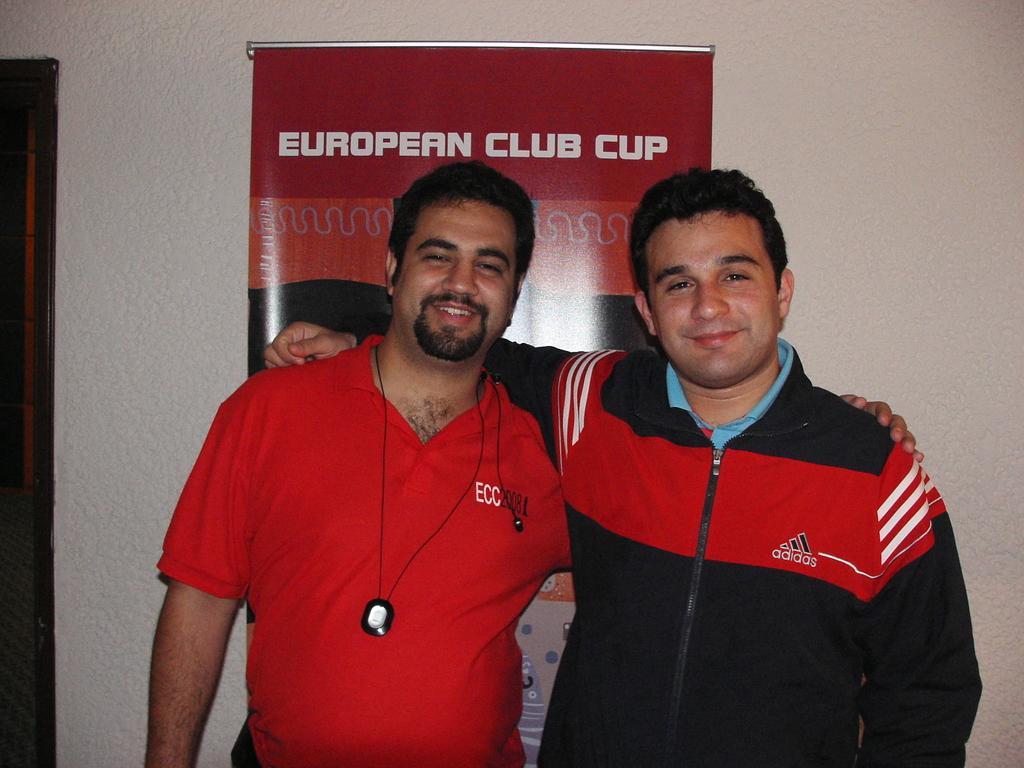What is written on the front of their shirts?
Keep it short and to the point. Adidas. 